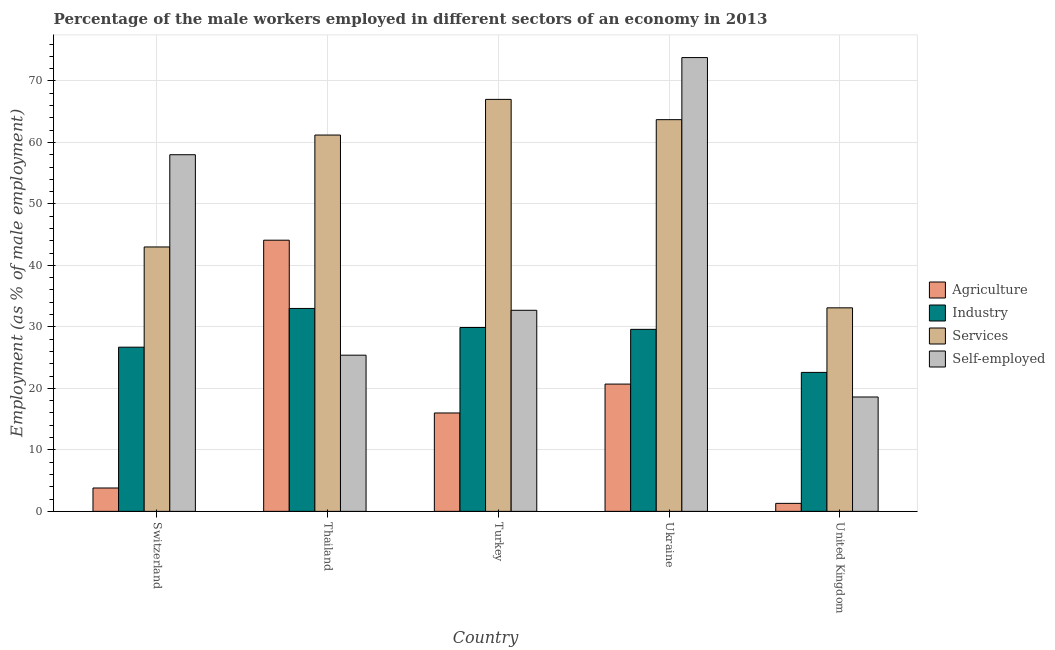How many different coloured bars are there?
Provide a short and direct response. 4. How many groups of bars are there?
Give a very brief answer. 5. How many bars are there on the 1st tick from the right?
Offer a terse response. 4. What is the label of the 3rd group of bars from the left?
Your answer should be compact. Turkey. What is the percentage of male workers in industry in Turkey?
Your answer should be very brief. 29.9. Across all countries, what is the maximum percentage of self employed male workers?
Ensure brevity in your answer.  73.8. Across all countries, what is the minimum percentage of male workers in industry?
Give a very brief answer. 22.6. What is the total percentage of male workers in services in the graph?
Ensure brevity in your answer.  268. What is the difference between the percentage of self employed male workers in Ukraine and that in United Kingdom?
Your answer should be compact. 55.2. What is the difference between the percentage of self employed male workers in Ukraine and the percentage of male workers in agriculture in Thailand?
Provide a succinct answer. 29.7. What is the average percentage of self employed male workers per country?
Offer a terse response. 41.7. What is the difference between the percentage of male workers in industry and percentage of self employed male workers in Ukraine?
Ensure brevity in your answer.  -44.2. What is the ratio of the percentage of self employed male workers in Turkey to that in United Kingdom?
Your answer should be compact. 1.76. Is the percentage of male workers in industry in Switzerland less than that in United Kingdom?
Provide a succinct answer. No. Is the difference between the percentage of self employed male workers in Turkey and United Kingdom greater than the difference between the percentage of male workers in services in Turkey and United Kingdom?
Keep it short and to the point. No. What is the difference between the highest and the second highest percentage of male workers in industry?
Keep it short and to the point. 3.1. What is the difference between the highest and the lowest percentage of male workers in services?
Make the answer very short. 33.9. Is the sum of the percentage of male workers in services in Thailand and United Kingdom greater than the maximum percentage of male workers in industry across all countries?
Ensure brevity in your answer.  Yes. What does the 1st bar from the left in United Kingdom represents?
Keep it short and to the point. Agriculture. What does the 2nd bar from the right in Turkey represents?
Ensure brevity in your answer.  Services. How many bars are there?
Your answer should be compact. 20. Are all the bars in the graph horizontal?
Keep it short and to the point. No. How many countries are there in the graph?
Make the answer very short. 5. Does the graph contain any zero values?
Give a very brief answer. No. How are the legend labels stacked?
Provide a short and direct response. Vertical. What is the title of the graph?
Provide a succinct answer. Percentage of the male workers employed in different sectors of an economy in 2013. Does "Bird species" appear as one of the legend labels in the graph?
Make the answer very short. No. What is the label or title of the X-axis?
Offer a very short reply. Country. What is the label or title of the Y-axis?
Offer a terse response. Employment (as % of male employment). What is the Employment (as % of male employment) of Agriculture in Switzerland?
Give a very brief answer. 3.8. What is the Employment (as % of male employment) in Industry in Switzerland?
Give a very brief answer. 26.7. What is the Employment (as % of male employment) of Agriculture in Thailand?
Ensure brevity in your answer.  44.1. What is the Employment (as % of male employment) in Industry in Thailand?
Keep it short and to the point. 33. What is the Employment (as % of male employment) of Services in Thailand?
Provide a short and direct response. 61.2. What is the Employment (as % of male employment) in Self-employed in Thailand?
Offer a terse response. 25.4. What is the Employment (as % of male employment) of Agriculture in Turkey?
Your response must be concise. 16. What is the Employment (as % of male employment) of Industry in Turkey?
Offer a very short reply. 29.9. What is the Employment (as % of male employment) of Services in Turkey?
Offer a terse response. 67. What is the Employment (as % of male employment) in Self-employed in Turkey?
Provide a short and direct response. 32.7. What is the Employment (as % of male employment) in Agriculture in Ukraine?
Give a very brief answer. 20.7. What is the Employment (as % of male employment) of Industry in Ukraine?
Make the answer very short. 29.6. What is the Employment (as % of male employment) in Services in Ukraine?
Give a very brief answer. 63.7. What is the Employment (as % of male employment) of Self-employed in Ukraine?
Provide a short and direct response. 73.8. What is the Employment (as % of male employment) in Agriculture in United Kingdom?
Keep it short and to the point. 1.3. What is the Employment (as % of male employment) of Industry in United Kingdom?
Keep it short and to the point. 22.6. What is the Employment (as % of male employment) in Services in United Kingdom?
Your answer should be compact. 33.1. What is the Employment (as % of male employment) of Self-employed in United Kingdom?
Offer a very short reply. 18.6. Across all countries, what is the maximum Employment (as % of male employment) in Agriculture?
Provide a succinct answer. 44.1. Across all countries, what is the maximum Employment (as % of male employment) of Industry?
Make the answer very short. 33. Across all countries, what is the maximum Employment (as % of male employment) in Services?
Ensure brevity in your answer.  67. Across all countries, what is the maximum Employment (as % of male employment) of Self-employed?
Your answer should be compact. 73.8. Across all countries, what is the minimum Employment (as % of male employment) of Agriculture?
Offer a very short reply. 1.3. Across all countries, what is the minimum Employment (as % of male employment) of Industry?
Your answer should be very brief. 22.6. Across all countries, what is the minimum Employment (as % of male employment) in Services?
Your answer should be compact. 33.1. Across all countries, what is the minimum Employment (as % of male employment) in Self-employed?
Offer a very short reply. 18.6. What is the total Employment (as % of male employment) in Agriculture in the graph?
Keep it short and to the point. 85.9. What is the total Employment (as % of male employment) in Industry in the graph?
Your answer should be very brief. 141.8. What is the total Employment (as % of male employment) of Services in the graph?
Provide a succinct answer. 268. What is the total Employment (as % of male employment) in Self-employed in the graph?
Your answer should be very brief. 208.5. What is the difference between the Employment (as % of male employment) of Agriculture in Switzerland and that in Thailand?
Your answer should be very brief. -40.3. What is the difference between the Employment (as % of male employment) in Industry in Switzerland and that in Thailand?
Your answer should be compact. -6.3. What is the difference between the Employment (as % of male employment) in Services in Switzerland and that in Thailand?
Ensure brevity in your answer.  -18.2. What is the difference between the Employment (as % of male employment) in Self-employed in Switzerland and that in Thailand?
Your answer should be compact. 32.6. What is the difference between the Employment (as % of male employment) of Agriculture in Switzerland and that in Turkey?
Your response must be concise. -12.2. What is the difference between the Employment (as % of male employment) in Services in Switzerland and that in Turkey?
Your answer should be very brief. -24. What is the difference between the Employment (as % of male employment) in Self-employed in Switzerland and that in Turkey?
Make the answer very short. 25.3. What is the difference between the Employment (as % of male employment) of Agriculture in Switzerland and that in Ukraine?
Make the answer very short. -16.9. What is the difference between the Employment (as % of male employment) of Industry in Switzerland and that in Ukraine?
Provide a succinct answer. -2.9. What is the difference between the Employment (as % of male employment) in Services in Switzerland and that in Ukraine?
Your answer should be compact. -20.7. What is the difference between the Employment (as % of male employment) in Self-employed in Switzerland and that in Ukraine?
Offer a very short reply. -15.8. What is the difference between the Employment (as % of male employment) of Services in Switzerland and that in United Kingdom?
Keep it short and to the point. 9.9. What is the difference between the Employment (as % of male employment) in Self-employed in Switzerland and that in United Kingdom?
Provide a short and direct response. 39.4. What is the difference between the Employment (as % of male employment) in Agriculture in Thailand and that in Turkey?
Give a very brief answer. 28.1. What is the difference between the Employment (as % of male employment) in Industry in Thailand and that in Turkey?
Offer a very short reply. 3.1. What is the difference between the Employment (as % of male employment) in Services in Thailand and that in Turkey?
Offer a very short reply. -5.8. What is the difference between the Employment (as % of male employment) of Self-employed in Thailand and that in Turkey?
Give a very brief answer. -7.3. What is the difference between the Employment (as % of male employment) of Agriculture in Thailand and that in Ukraine?
Provide a short and direct response. 23.4. What is the difference between the Employment (as % of male employment) of Industry in Thailand and that in Ukraine?
Your response must be concise. 3.4. What is the difference between the Employment (as % of male employment) of Self-employed in Thailand and that in Ukraine?
Ensure brevity in your answer.  -48.4. What is the difference between the Employment (as % of male employment) of Agriculture in Thailand and that in United Kingdom?
Ensure brevity in your answer.  42.8. What is the difference between the Employment (as % of male employment) in Industry in Thailand and that in United Kingdom?
Offer a very short reply. 10.4. What is the difference between the Employment (as % of male employment) in Services in Thailand and that in United Kingdom?
Your answer should be very brief. 28.1. What is the difference between the Employment (as % of male employment) in Self-employed in Thailand and that in United Kingdom?
Your answer should be compact. 6.8. What is the difference between the Employment (as % of male employment) of Agriculture in Turkey and that in Ukraine?
Keep it short and to the point. -4.7. What is the difference between the Employment (as % of male employment) in Industry in Turkey and that in Ukraine?
Give a very brief answer. 0.3. What is the difference between the Employment (as % of male employment) of Services in Turkey and that in Ukraine?
Ensure brevity in your answer.  3.3. What is the difference between the Employment (as % of male employment) in Self-employed in Turkey and that in Ukraine?
Keep it short and to the point. -41.1. What is the difference between the Employment (as % of male employment) of Agriculture in Turkey and that in United Kingdom?
Make the answer very short. 14.7. What is the difference between the Employment (as % of male employment) of Services in Turkey and that in United Kingdom?
Provide a short and direct response. 33.9. What is the difference between the Employment (as % of male employment) of Services in Ukraine and that in United Kingdom?
Provide a succinct answer. 30.6. What is the difference between the Employment (as % of male employment) in Self-employed in Ukraine and that in United Kingdom?
Give a very brief answer. 55.2. What is the difference between the Employment (as % of male employment) of Agriculture in Switzerland and the Employment (as % of male employment) of Industry in Thailand?
Provide a short and direct response. -29.2. What is the difference between the Employment (as % of male employment) of Agriculture in Switzerland and the Employment (as % of male employment) of Services in Thailand?
Your response must be concise. -57.4. What is the difference between the Employment (as % of male employment) in Agriculture in Switzerland and the Employment (as % of male employment) in Self-employed in Thailand?
Provide a short and direct response. -21.6. What is the difference between the Employment (as % of male employment) of Industry in Switzerland and the Employment (as % of male employment) of Services in Thailand?
Provide a short and direct response. -34.5. What is the difference between the Employment (as % of male employment) of Services in Switzerland and the Employment (as % of male employment) of Self-employed in Thailand?
Provide a short and direct response. 17.6. What is the difference between the Employment (as % of male employment) in Agriculture in Switzerland and the Employment (as % of male employment) in Industry in Turkey?
Your answer should be very brief. -26.1. What is the difference between the Employment (as % of male employment) in Agriculture in Switzerland and the Employment (as % of male employment) in Services in Turkey?
Ensure brevity in your answer.  -63.2. What is the difference between the Employment (as % of male employment) of Agriculture in Switzerland and the Employment (as % of male employment) of Self-employed in Turkey?
Give a very brief answer. -28.9. What is the difference between the Employment (as % of male employment) in Industry in Switzerland and the Employment (as % of male employment) in Services in Turkey?
Provide a short and direct response. -40.3. What is the difference between the Employment (as % of male employment) of Services in Switzerland and the Employment (as % of male employment) of Self-employed in Turkey?
Your response must be concise. 10.3. What is the difference between the Employment (as % of male employment) of Agriculture in Switzerland and the Employment (as % of male employment) of Industry in Ukraine?
Your answer should be compact. -25.8. What is the difference between the Employment (as % of male employment) of Agriculture in Switzerland and the Employment (as % of male employment) of Services in Ukraine?
Give a very brief answer. -59.9. What is the difference between the Employment (as % of male employment) of Agriculture in Switzerland and the Employment (as % of male employment) of Self-employed in Ukraine?
Offer a very short reply. -70. What is the difference between the Employment (as % of male employment) of Industry in Switzerland and the Employment (as % of male employment) of Services in Ukraine?
Provide a short and direct response. -37. What is the difference between the Employment (as % of male employment) of Industry in Switzerland and the Employment (as % of male employment) of Self-employed in Ukraine?
Make the answer very short. -47.1. What is the difference between the Employment (as % of male employment) in Services in Switzerland and the Employment (as % of male employment) in Self-employed in Ukraine?
Your answer should be very brief. -30.8. What is the difference between the Employment (as % of male employment) in Agriculture in Switzerland and the Employment (as % of male employment) in Industry in United Kingdom?
Make the answer very short. -18.8. What is the difference between the Employment (as % of male employment) of Agriculture in Switzerland and the Employment (as % of male employment) of Services in United Kingdom?
Offer a very short reply. -29.3. What is the difference between the Employment (as % of male employment) of Agriculture in Switzerland and the Employment (as % of male employment) of Self-employed in United Kingdom?
Make the answer very short. -14.8. What is the difference between the Employment (as % of male employment) in Industry in Switzerland and the Employment (as % of male employment) in Services in United Kingdom?
Make the answer very short. -6.4. What is the difference between the Employment (as % of male employment) in Services in Switzerland and the Employment (as % of male employment) in Self-employed in United Kingdom?
Provide a succinct answer. 24.4. What is the difference between the Employment (as % of male employment) of Agriculture in Thailand and the Employment (as % of male employment) of Services in Turkey?
Provide a short and direct response. -22.9. What is the difference between the Employment (as % of male employment) of Agriculture in Thailand and the Employment (as % of male employment) of Self-employed in Turkey?
Offer a very short reply. 11.4. What is the difference between the Employment (as % of male employment) of Industry in Thailand and the Employment (as % of male employment) of Services in Turkey?
Give a very brief answer. -34. What is the difference between the Employment (as % of male employment) in Agriculture in Thailand and the Employment (as % of male employment) in Industry in Ukraine?
Give a very brief answer. 14.5. What is the difference between the Employment (as % of male employment) of Agriculture in Thailand and the Employment (as % of male employment) of Services in Ukraine?
Your answer should be compact. -19.6. What is the difference between the Employment (as % of male employment) of Agriculture in Thailand and the Employment (as % of male employment) of Self-employed in Ukraine?
Ensure brevity in your answer.  -29.7. What is the difference between the Employment (as % of male employment) in Industry in Thailand and the Employment (as % of male employment) in Services in Ukraine?
Your response must be concise. -30.7. What is the difference between the Employment (as % of male employment) of Industry in Thailand and the Employment (as % of male employment) of Self-employed in Ukraine?
Offer a terse response. -40.8. What is the difference between the Employment (as % of male employment) of Services in Thailand and the Employment (as % of male employment) of Self-employed in United Kingdom?
Provide a short and direct response. 42.6. What is the difference between the Employment (as % of male employment) of Agriculture in Turkey and the Employment (as % of male employment) of Services in Ukraine?
Make the answer very short. -47.7. What is the difference between the Employment (as % of male employment) of Agriculture in Turkey and the Employment (as % of male employment) of Self-employed in Ukraine?
Offer a terse response. -57.8. What is the difference between the Employment (as % of male employment) of Industry in Turkey and the Employment (as % of male employment) of Services in Ukraine?
Offer a terse response. -33.8. What is the difference between the Employment (as % of male employment) of Industry in Turkey and the Employment (as % of male employment) of Self-employed in Ukraine?
Your answer should be compact. -43.9. What is the difference between the Employment (as % of male employment) in Agriculture in Turkey and the Employment (as % of male employment) in Industry in United Kingdom?
Ensure brevity in your answer.  -6.6. What is the difference between the Employment (as % of male employment) of Agriculture in Turkey and the Employment (as % of male employment) of Services in United Kingdom?
Your answer should be compact. -17.1. What is the difference between the Employment (as % of male employment) of Agriculture in Turkey and the Employment (as % of male employment) of Self-employed in United Kingdom?
Ensure brevity in your answer.  -2.6. What is the difference between the Employment (as % of male employment) of Industry in Turkey and the Employment (as % of male employment) of Services in United Kingdom?
Keep it short and to the point. -3.2. What is the difference between the Employment (as % of male employment) in Industry in Turkey and the Employment (as % of male employment) in Self-employed in United Kingdom?
Give a very brief answer. 11.3. What is the difference between the Employment (as % of male employment) of Services in Turkey and the Employment (as % of male employment) of Self-employed in United Kingdom?
Ensure brevity in your answer.  48.4. What is the difference between the Employment (as % of male employment) of Agriculture in Ukraine and the Employment (as % of male employment) of Industry in United Kingdom?
Give a very brief answer. -1.9. What is the difference between the Employment (as % of male employment) in Agriculture in Ukraine and the Employment (as % of male employment) in Services in United Kingdom?
Offer a very short reply. -12.4. What is the difference between the Employment (as % of male employment) of Services in Ukraine and the Employment (as % of male employment) of Self-employed in United Kingdom?
Provide a short and direct response. 45.1. What is the average Employment (as % of male employment) in Agriculture per country?
Offer a very short reply. 17.18. What is the average Employment (as % of male employment) of Industry per country?
Give a very brief answer. 28.36. What is the average Employment (as % of male employment) in Services per country?
Your answer should be compact. 53.6. What is the average Employment (as % of male employment) in Self-employed per country?
Keep it short and to the point. 41.7. What is the difference between the Employment (as % of male employment) of Agriculture and Employment (as % of male employment) of Industry in Switzerland?
Your response must be concise. -22.9. What is the difference between the Employment (as % of male employment) of Agriculture and Employment (as % of male employment) of Services in Switzerland?
Your response must be concise. -39.2. What is the difference between the Employment (as % of male employment) of Agriculture and Employment (as % of male employment) of Self-employed in Switzerland?
Offer a terse response. -54.2. What is the difference between the Employment (as % of male employment) in Industry and Employment (as % of male employment) in Services in Switzerland?
Provide a short and direct response. -16.3. What is the difference between the Employment (as % of male employment) of Industry and Employment (as % of male employment) of Self-employed in Switzerland?
Your response must be concise. -31.3. What is the difference between the Employment (as % of male employment) in Services and Employment (as % of male employment) in Self-employed in Switzerland?
Offer a terse response. -15. What is the difference between the Employment (as % of male employment) in Agriculture and Employment (as % of male employment) in Industry in Thailand?
Keep it short and to the point. 11.1. What is the difference between the Employment (as % of male employment) of Agriculture and Employment (as % of male employment) of Services in Thailand?
Make the answer very short. -17.1. What is the difference between the Employment (as % of male employment) of Agriculture and Employment (as % of male employment) of Self-employed in Thailand?
Your answer should be very brief. 18.7. What is the difference between the Employment (as % of male employment) of Industry and Employment (as % of male employment) of Services in Thailand?
Give a very brief answer. -28.2. What is the difference between the Employment (as % of male employment) in Services and Employment (as % of male employment) in Self-employed in Thailand?
Offer a very short reply. 35.8. What is the difference between the Employment (as % of male employment) of Agriculture and Employment (as % of male employment) of Industry in Turkey?
Your response must be concise. -13.9. What is the difference between the Employment (as % of male employment) of Agriculture and Employment (as % of male employment) of Services in Turkey?
Give a very brief answer. -51. What is the difference between the Employment (as % of male employment) of Agriculture and Employment (as % of male employment) of Self-employed in Turkey?
Keep it short and to the point. -16.7. What is the difference between the Employment (as % of male employment) in Industry and Employment (as % of male employment) in Services in Turkey?
Provide a succinct answer. -37.1. What is the difference between the Employment (as % of male employment) in Industry and Employment (as % of male employment) in Self-employed in Turkey?
Make the answer very short. -2.8. What is the difference between the Employment (as % of male employment) in Services and Employment (as % of male employment) in Self-employed in Turkey?
Ensure brevity in your answer.  34.3. What is the difference between the Employment (as % of male employment) of Agriculture and Employment (as % of male employment) of Services in Ukraine?
Your answer should be compact. -43. What is the difference between the Employment (as % of male employment) of Agriculture and Employment (as % of male employment) of Self-employed in Ukraine?
Ensure brevity in your answer.  -53.1. What is the difference between the Employment (as % of male employment) in Industry and Employment (as % of male employment) in Services in Ukraine?
Your response must be concise. -34.1. What is the difference between the Employment (as % of male employment) of Industry and Employment (as % of male employment) of Self-employed in Ukraine?
Give a very brief answer. -44.2. What is the difference between the Employment (as % of male employment) in Services and Employment (as % of male employment) in Self-employed in Ukraine?
Your response must be concise. -10.1. What is the difference between the Employment (as % of male employment) of Agriculture and Employment (as % of male employment) of Industry in United Kingdom?
Give a very brief answer. -21.3. What is the difference between the Employment (as % of male employment) in Agriculture and Employment (as % of male employment) in Services in United Kingdom?
Your response must be concise. -31.8. What is the difference between the Employment (as % of male employment) in Agriculture and Employment (as % of male employment) in Self-employed in United Kingdom?
Provide a succinct answer. -17.3. What is the difference between the Employment (as % of male employment) in Industry and Employment (as % of male employment) in Services in United Kingdom?
Your answer should be very brief. -10.5. What is the difference between the Employment (as % of male employment) of Industry and Employment (as % of male employment) of Self-employed in United Kingdom?
Ensure brevity in your answer.  4. What is the ratio of the Employment (as % of male employment) of Agriculture in Switzerland to that in Thailand?
Offer a terse response. 0.09. What is the ratio of the Employment (as % of male employment) in Industry in Switzerland to that in Thailand?
Make the answer very short. 0.81. What is the ratio of the Employment (as % of male employment) in Services in Switzerland to that in Thailand?
Your answer should be compact. 0.7. What is the ratio of the Employment (as % of male employment) of Self-employed in Switzerland to that in Thailand?
Offer a terse response. 2.28. What is the ratio of the Employment (as % of male employment) of Agriculture in Switzerland to that in Turkey?
Your answer should be compact. 0.24. What is the ratio of the Employment (as % of male employment) of Industry in Switzerland to that in Turkey?
Your answer should be very brief. 0.89. What is the ratio of the Employment (as % of male employment) of Services in Switzerland to that in Turkey?
Make the answer very short. 0.64. What is the ratio of the Employment (as % of male employment) in Self-employed in Switzerland to that in Turkey?
Your answer should be compact. 1.77. What is the ratio of the Employment (as % of male employment) of Agriculture in Switzerland to that in Ukraine?
Offer a very short reply. 0.18. What is the ratio of the Employment (as % of male employment) of Industry in Switzerland to that in Ukraine?
Keep it short and to the point. 0.9. What is the ratio of the Employment (as % of male employment) of Services in Switzerland to that in Ukraine?
Ensure brevity in your answer.  0.68. What is the ratio of the Employment (as % of male employment) in Self-employed in Switzerland to that in Ukraine?
Ensure brevity in your answer.  0.79. What is the ratio of the Employment (as % of male employment) of Agriculture in Switzerland to that in United Kingdom?
Give a very brief answer. 2.92. What is the ratio of the Employment (as % of male employment) of Industry in Switzerland to that in United Kingdom?
Offer a very short reply. 1.18. What is the ratio of the Employment (as % of male employment) in Services in Switzerland to that in United Kingdom?
Provide a short and direct response. 1.3. What is the ratio of the Employment (as % of male employment) in Self-employed in Switzerland to that in United Kingdom?
Your response must be concise. 3.12. What is the ratio of the Employment (as % of male employment) in Agriculture in Thailand to that in Turkey?
Offer a very short reply. 2.76. What is the ratio of the Employment (as % of male employment) in Industry in Thailand to that in Turkey?
Your answer should be compact. 1.1. What is the ratio of the Employment (as % of male employment) in Services in Thailand to that in Turkey?
Your response must be concise. 0.91. What is the ratio of the Employment (as % of male employment) in Self-employed in Thailand to that in Turkey?
Keep it short and to the point. 0.78. What is the ratio of the Employment (as % of male employment) in Agriculture in Thailand to that in Ukraine?
Your answer should be compact. 2.13. What is the ratio of the Employment (as % of male employment) in Industry in Thailand to that in Ukraine?
Offer a terse response. 1.11. What is the ratio of the Employment (as % of male employment) of Services in Thailand to that in Ukraine?
Your answer should be very brief. 0.96. What is the ratio of the Employment (as % of male employment) in Self-employed in Thailand to that in Ukraine?
Provide a succinct answer. 0.34. What is the ratio of the Employment (as % of male employment) in Agriculture in Thailand to that in United Kingdom?
Provide a short and direct response. 33.92. What is the ratio of the Employment (as % of male employment) of Industry in Thailand to that in United Kingdom?
Offer a terse response. 1.46. What is the ratio of the Employment (as % of male employment) in Services in Thailand to that in United Kingdom?
Offer a terse response. 1.85. What is the ratio of the Employment (as % of male employment) of Self-employed in Thailand to that in United Kingdom?
Offer a very short reply. 1.37. What is the ratio of the Employment (as % of male employment) of Agriculture in Turkey to that in Ukraine?
Offer a terse response. 0.77. What is the ratio of the Employment (as % of male employment) in Services in Turkey to that in Ukraine?
Provide a short and direct response. 1.05. What is the ratio of the Employment (as % of male employment) in Self-employed in Turkey to that in Ukraine?
Offer a very short reply. 0.44. What is the ratio of the Employment (as % of male employment) in Agriculture in Turkey to that in United Kingdom?
Your response must be concise. 12.31. What is the ratio of the Employment (as % of male employment) of Industry in Turkey to that in United Kingdom?
Provide a succinct answer. 1.32. What is the ratio of the Employment (as % of male employment) in Services in Turkey to that in United Kingdom?
Offer a very short reply. 2.02. What is the ratio of the Employment (as % of male employment) of Self-employed in Turkey to that in United Kingdom?
Keep it short and to the point. 1.76. What is the ratio of the Employment (as % of male employment) in Agriculture in Ukraine to that in United Kingdom?
Ensure brevity in your answer.  15.92. What is the ratio of the Employment (as % of male employment) in Industry in Ukraine to that in United Kingdom?
Your answer should be very brief. 1.31. What is the ratio of the Employment (as % of male employment) of Services in Ukraine to that in United Kingdom?
Offer a terse response. 1.92. What is the ratio of the Employment (as % of male employment) of Self-employed in Ukraine to that in United Kingdom?
Your response must be concise. 3.97. What is the difference between the highest and the second highest Employment (as % of male employment) in Agriculture?
Provide a short and direct response. 23.4. What is the difference between the highest and the second highest Employment (as % of male employment) in Services?
Keep it short and to the point. 3.3. What is the difference between the highest and the second highest Employment (as % of male employment) in Self-employed?
Your answer should be very brief. 15.8. What is the difference between the highest and the lowest Employment (as % of male employment) of Agriculture?
Keep it short and to the point. 42.8. What is the difference between the highest and the lowest Employment (as % of male employment) of Industry?
Ensure brevity in your answer.  10.4. What is the difference between the highest and the lowest Employment (as % of male employment) of Services?
Provide a succinct answer. 33.9. What is the difference between the highest and the lowest Employment (as % of male employment) in Self-employed?
Your answer should be very brief. 55.2. 